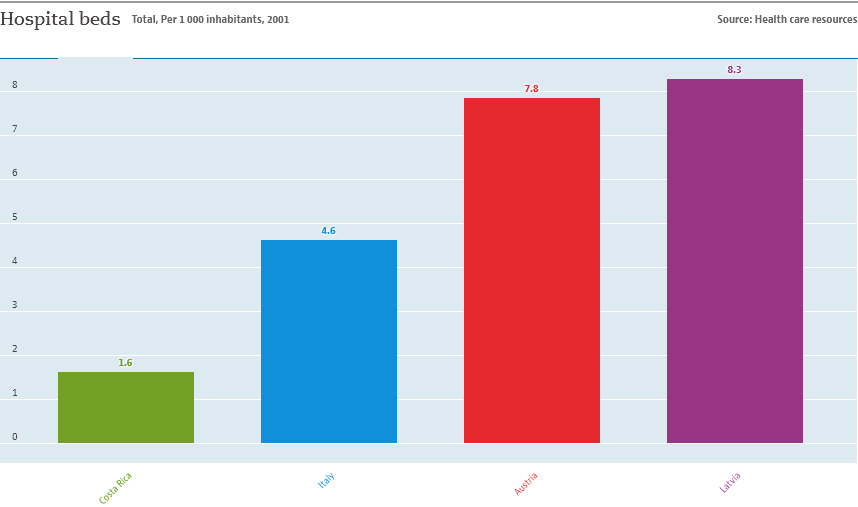List a handful of essential elements in this visual. The average data of all countries includes 22.3. I need to locate data related to Italy for the question number 4.6. 